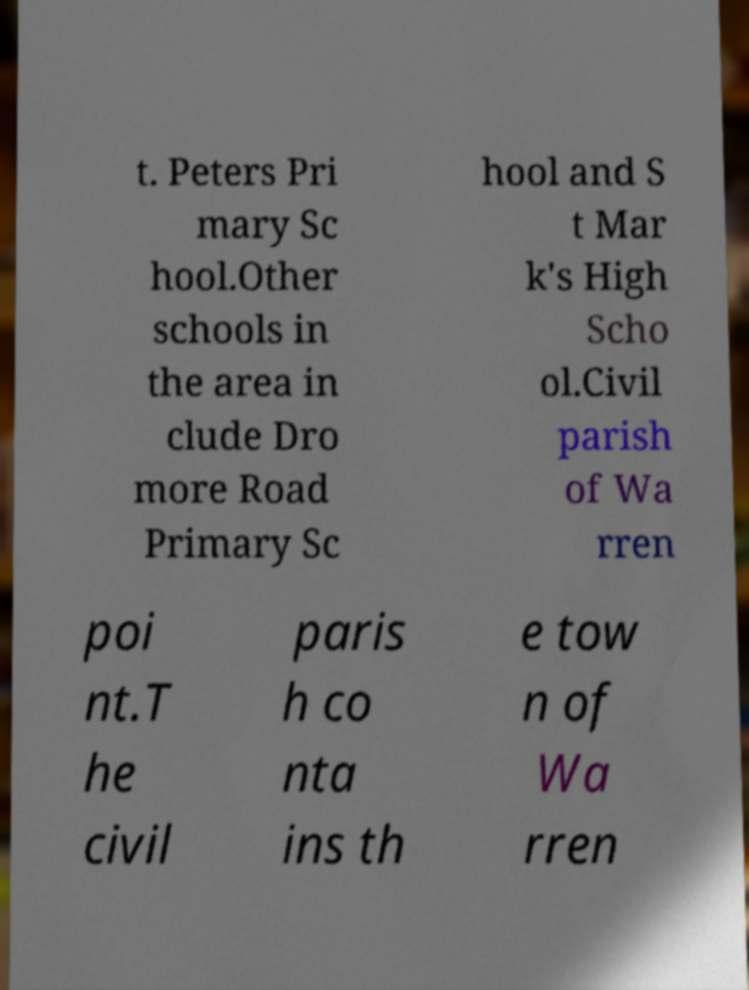What messages or text are displayed in this image? I need them in a readable, typed format. t. Peters Pri mary Sc hool.Other schools in the area in clude Dro more Road Primary Sc hool and S t Mar k's High Scho ol.Civil parish of Wa rren poi nt.T he civil paris h co nta ins th e tow n of Wa rren 